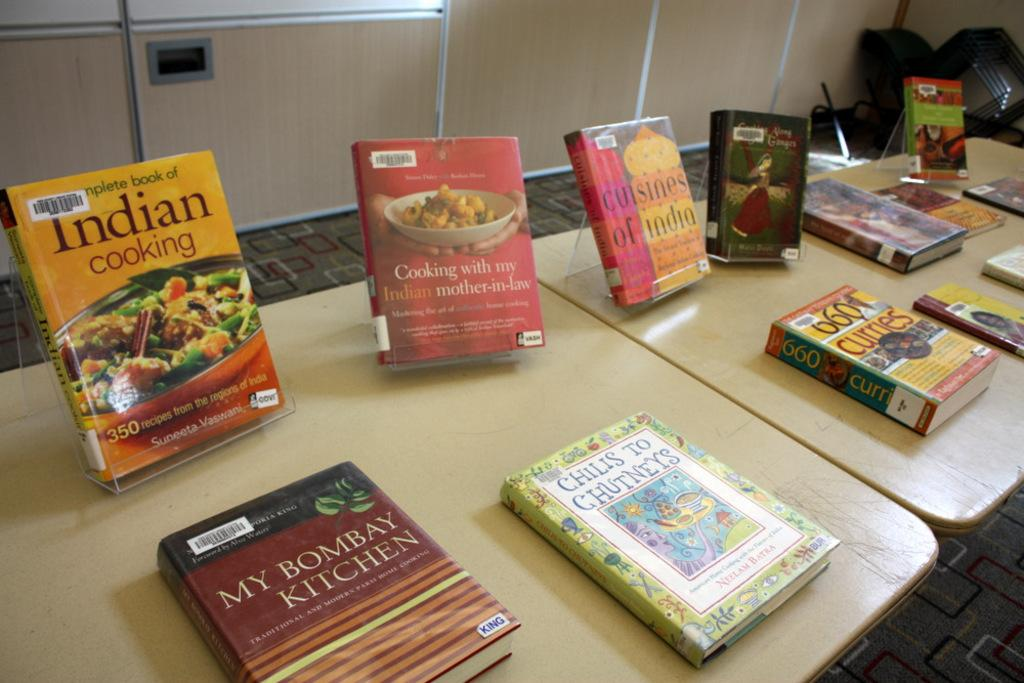<image>
Share a concise interpretation of the image provided. A series of cooking books such as My Bombay Kitchen and Indian Cooking sitting on a table. 